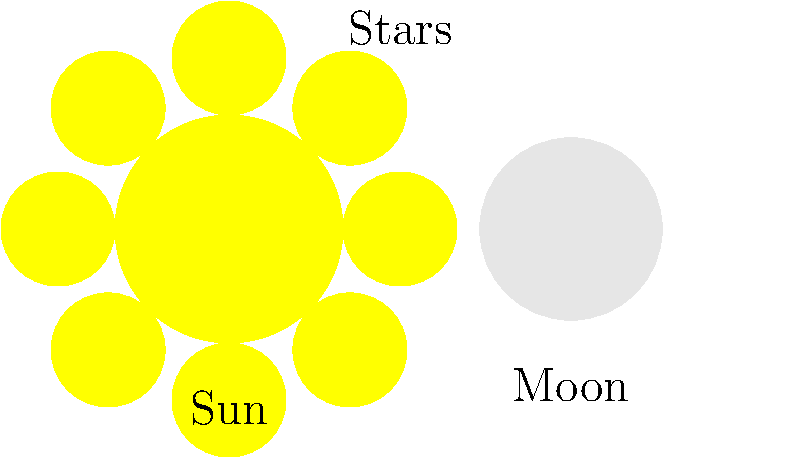In Hindu iconography, which celestial body is often associated with Lord Shiva and depicted on his forehead? To answer this question, let's consider the following steps:

1. Recall that Hindu deities are often associated with celestial bodies in iconography.

2. Lord Shiva, one of the principal deities in Hinduism, is known for his distinctive iconography.

3. One of the most recognizable features in Shiva's depiction is the crescent moon on his forehead.

4. The moon holds significant symbolism in Shiva's iconography:
   a) It represents Shiva's control over time, as the moon waxes and wanes.
   b) It symbolizes the cyclical nature of creation and destruction.
   c) In some interpretations, it represents wisdom and beauty.

5. Other celestial bodies are also important in Hindu iconography, but they are typically associated with other deities:
   a) The Sun is often associated with Surya, the sun god.
   b) Stars are sometimes associated with various deities or celestial beings.

6. However, the crescent moon is uniquely and consistently associated with Shiva in Hindu art and literature.

Therefore, the celestial body most commonly associated with Lord Shiva and depicted on his forehead is the moon, specifically in its crescent form.
Answer: The Moon (crescent) 